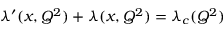<formula> <loc_0><loc_0><loc_500><loc_500>\lambda ^ { \prime } ( x , Q ^ { 2 } ) + \lambda ( x , Q ^ { 2 } ) = \lambda _ { c } ( Q ^ { 2 } )</formula> 